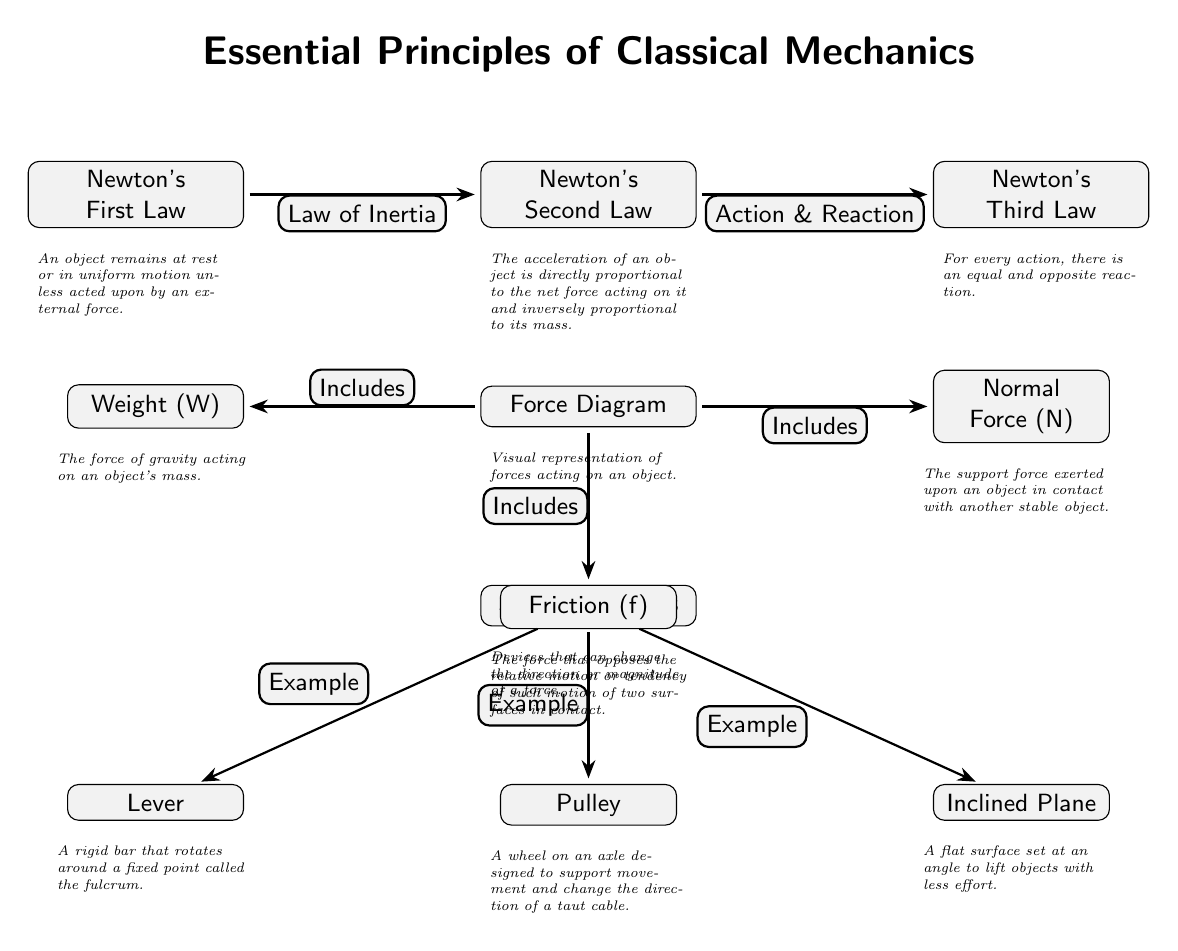What is the first law of Newton? The diagram states that Newton's First Law relates to an object's state of rest or uniform motion. Specifically, it says that an object remains at rest or in uniform motion unless acted upon by an external force. This can be directly read from the label under the node for Newton's First Law.
Answer: Law of Inertia How many simple machines are listed in the diagram? The diagram shows three simple machines represented in nodes below the "Simple Machines" node. These are Lever, Pulley, and Inclined Plane. By counting these nodes, we determine the number.
Answer: 3 What does the Force Diagram represent? In the diagram, there's a node labeled "Force Diagram," which is accompanied by a note that states it is a visual representation of forces acting on an object. This connection makes it clear what the purpose of this node is.
Answer: Visual representation of forces acting on an object Which law states "For every action, there is an equal and opposite reaction"? The diagram contains Newton's Third Law, which specifically includes that phrase. This law is directly labeled in the corresponding node, making it possible to directly answer the question based on the diagram.
Answer: Newton's Third Law What force opposes the relative motion of two surfaces? The diagram identifies Friction as the force opposing motion, presented in the Force Diagram section. The note under this force clearly defines it, allowing for easy extraction of the answer from the visual context.
Answer: Friction Explain the relationship between the second and third Newton's laws in the diagram. The diagram indicates that Newton's Second Law deals with the relationship between acceleration, net force, and mass. Additionally, it shows that Newton's Third Law is linked to the interaction described as action and reaction. Therefore, the connection is that Newton's Second Law describes how forces influence motion, while the Third Law encompasses the reciprocal nature of those forces. Together, these laws provide a comprehensive understanding of motion and force interaction.
Answer: Action & Reaction What simple machine allows lifting objects with less effort? In the diagram, the Inclined Plane is specifically defined in the note associated with its node, stating it is a flat surface set at an angle for lifting objects more easily. Thus, it directly answers the question regarding which device is used for this purpose.
Answer: Inclined Plane What is the support force called that acts on an object in contact with another? The diagram specifies the Normal Force under the Force Diagram section, indicating its role as the support force for objects in contact. The definition provided in the note clarifies its function, allowing for straightforward identification.
Answer: Normal Force 